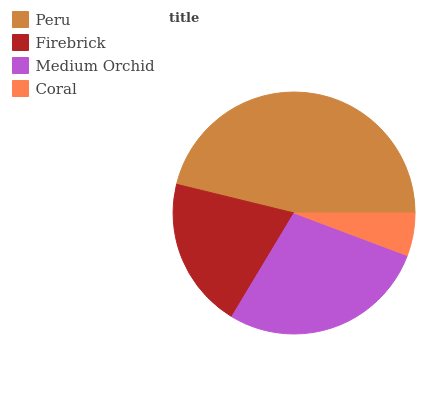Is Coral the minimum?
Answer yes or no. Yes. Is Peru the maximum?
Answer yes or no. Yes. Is Firebrick the minimum?
Answer yes or no. No. Is Firebrick the maximum?
Answer yes or no. No. Is Peru greater than Firebrick?
Answer yes or no. Yes. Is Firebrick less than Peru?
Answer yes or no. Yes. Is Firebrick greater than Peru?
Answer yes or no. No. Is Peru less than Firebrick?
Answer yes or no. No. Is Medium Orchid the high median?
Answer yes or no. Yes. Is Firebrick the low median?
Answer yes or no. Yes. Is Peru the high median?
Answer yes or no. No. Is Medium Orchid the low median?
Answer yes or no. No. 